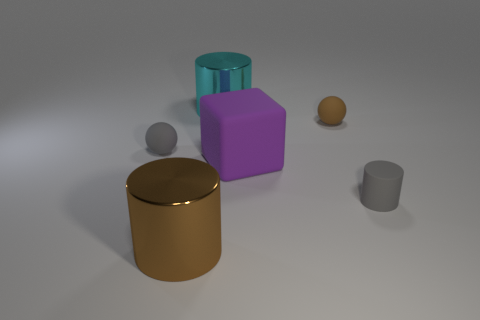Add 2 small brown rubber objects. How many objects exist? 8 Subtract all balls. How many objects are left? 4 Subtract all brown matte balls. Subtract all gray balls. How many objects are left? 4 Add 2 tiny gray rubber balls. How many tiny gray rubber balls are left? 3 Add 4 metallic cylinders. How many metallic cylinders exist? 6 Subtract 0 green cylinders. How many objects are left? 6 